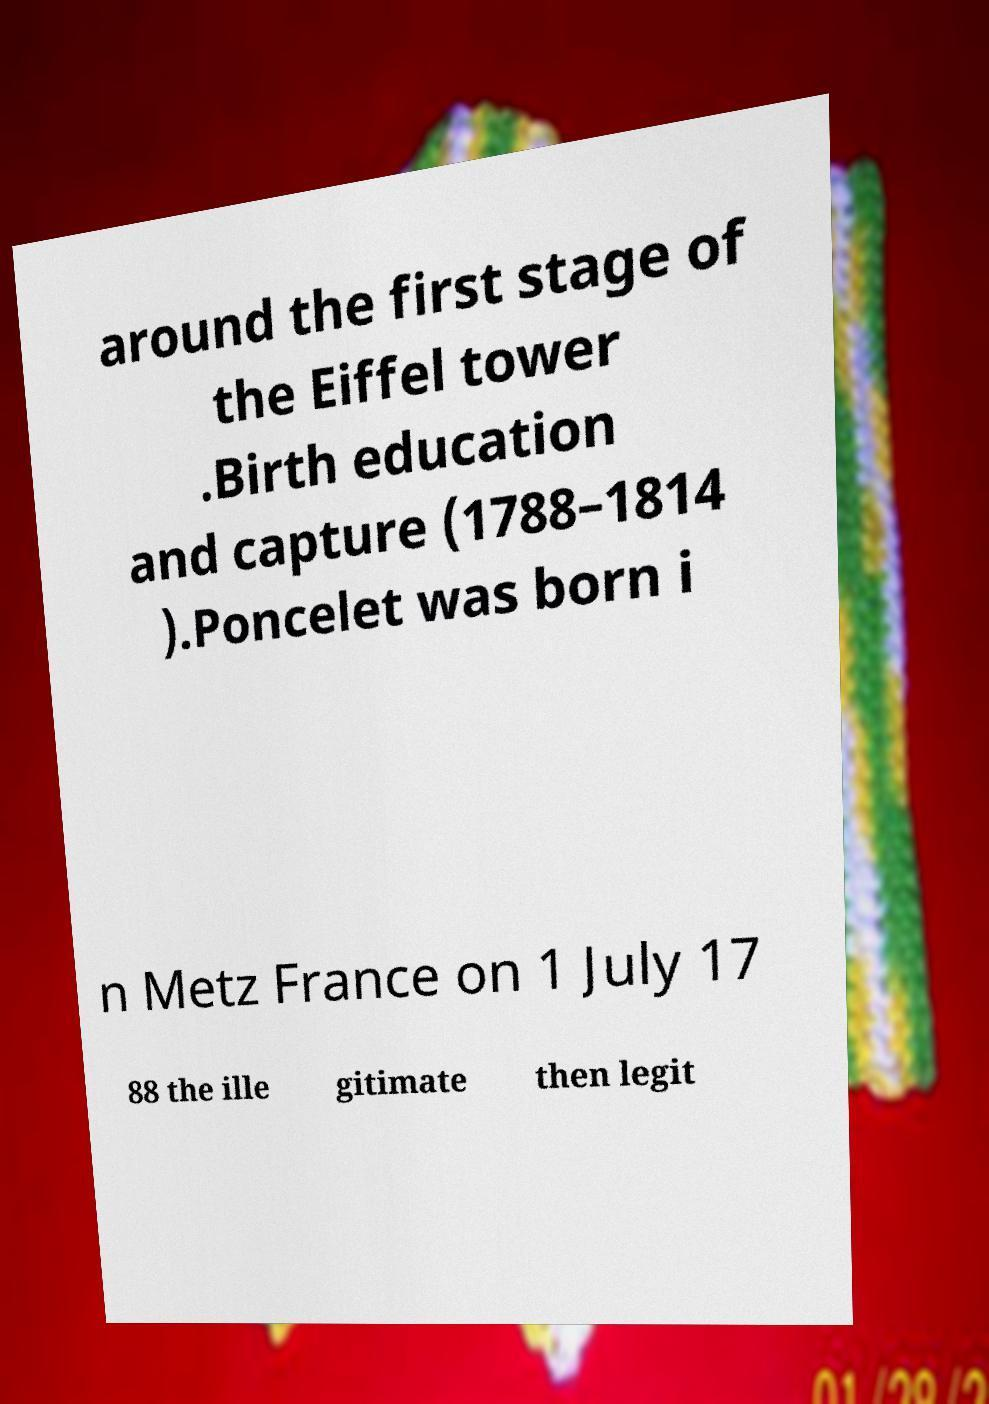Could you assist in decoding the text presented in this image and type it out clearly? around the first stage of the Eiffel tower .Birth education and capture (1788–1814 ).Poncelet was born i n Metz France on 1 July 17 88 the ille gitimate then legit 